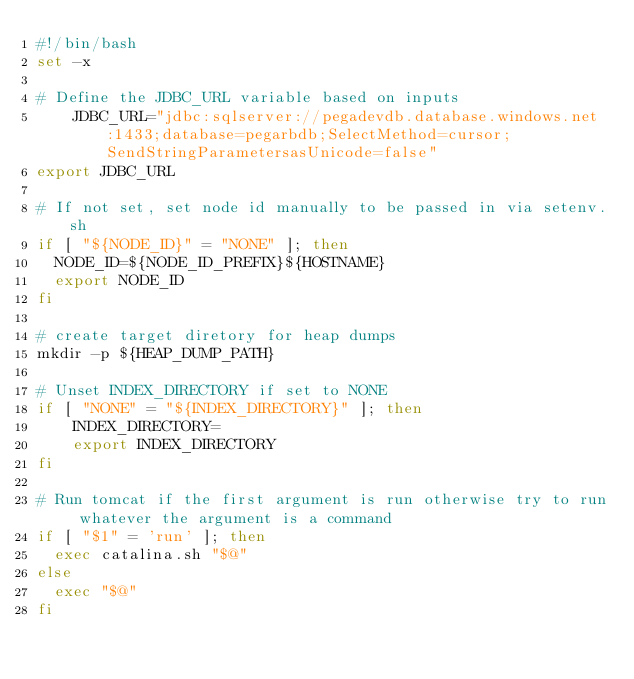Convert code to text. <code><loc_0><loc_0><loc_500><loc_500><_Bash_>#!/bin/bash
set -x

# Define the JDBC_URL variable based on inputs
    JDBC_URL="jdbc:sqlserver://pegadevdb.database.windows.net:1433;database=pegarbdb;SelectMethod=cursor;SendStringParametersasUnicode=false"
export JDBC_URL

# If not set, set node id manually to be passed in via setenv.sh
if [ "${NODE_ID}" = "NONE" ]; then
  NODE_ID=${NODE_ID_PREFIX}${HOSTNAME}
  export NODE_ID
fi

# create target diretory for heap dumps
mkdir -p ${HEAP_DUMP_PATH}

# Unset INDEX_DIRECTORY if set to NONE
if [ "NONE" = "${INDEX_DIRECTORY}" ]; then
    INDEX_DIRECTORY=
    export INDEX_DIRECTORY
fi

# Run tomcat if the first argument is run otherwise try to run whatever the argument is a command
if [ "$1" = 'run' ]; then
  exec catalina.sh "$@"
else
  exec "$@"
fi
</code> 